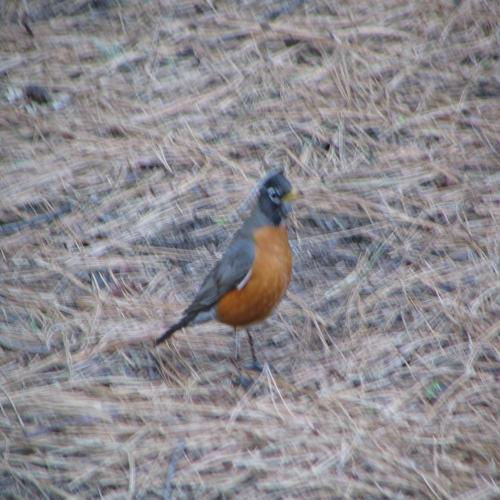Is the main subject of the image a bird on the grass?
 Yes 